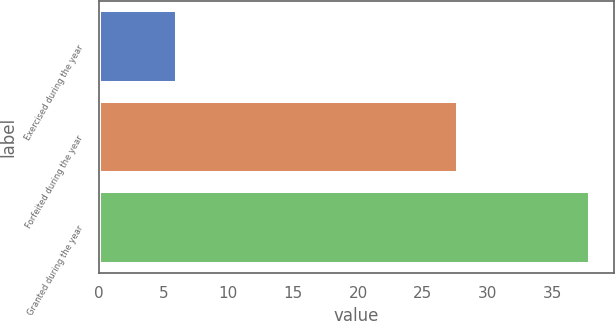<chart> <loc_0><loc_0><loc_500><loc_500><bar_chart><fcel>Exercised during the year<fcel>Forfeited during the year<fcel>Granted during the year<nl><fcel>6.01<fcel>27.71<fcel>37.86<nl></chart> 